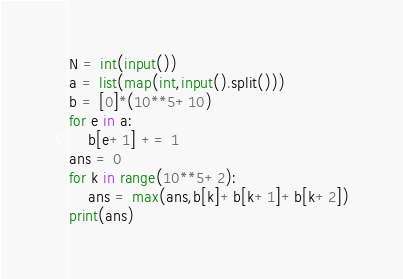Convert code to text. <code><loc_0><loc_0><loc_500><loc_500><_Python_>N = int(input())
a = list(map(int,input().split()))
b = [0]*(10**5+10)
for e in a:
    b[e+1] += 1
ans = 0
for k in range(10**5+2):
    ans = max(ans,b[k]+b[k+1]+b[k+2])
print(ans)
</code> 